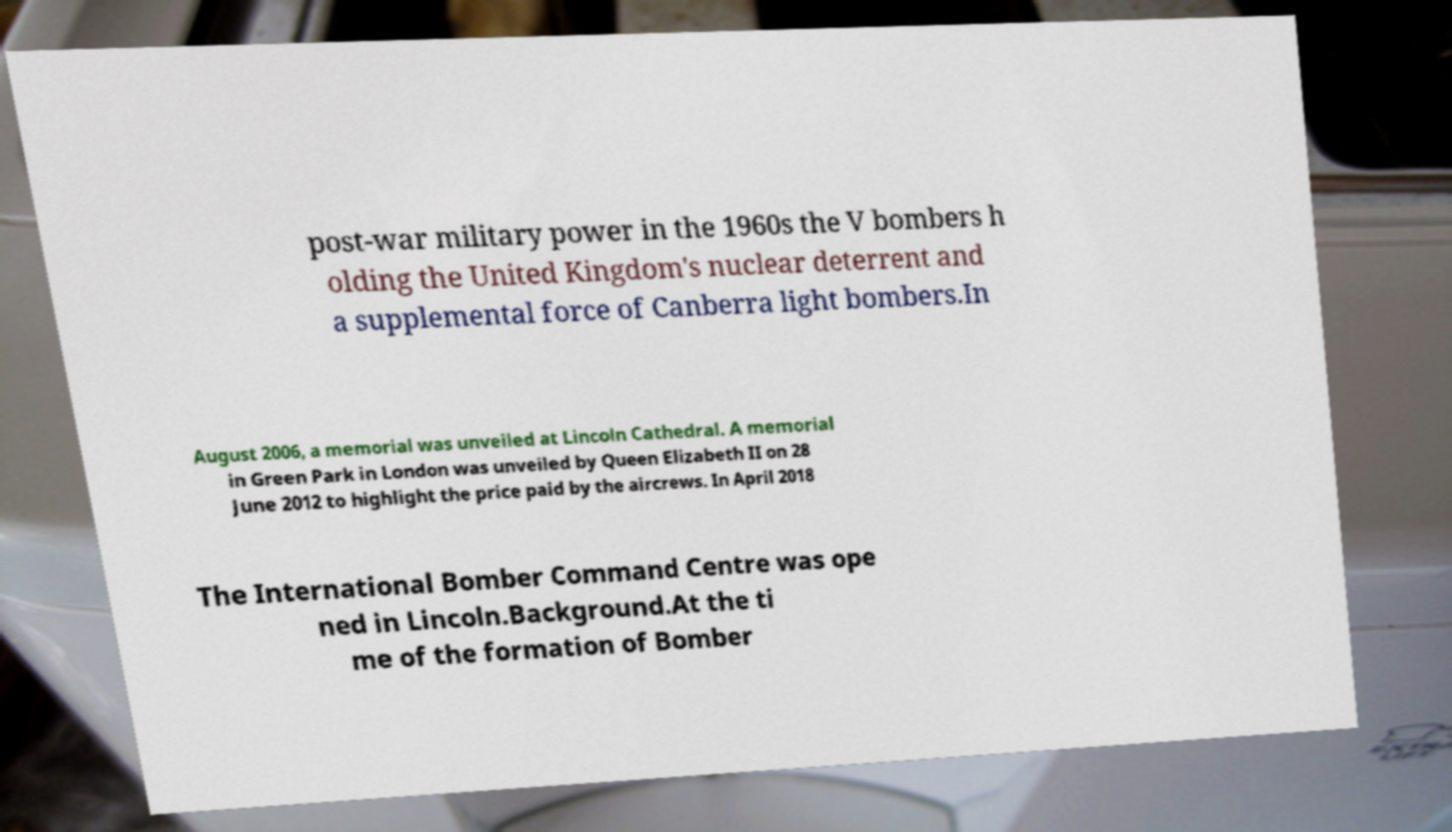Can you read and provide the text displayed in the image?This photo seems to have some interesting text. Can you extract and type it out for me? post-war military power in the 1960s the V bombers h olding the United Kingdom's nuclear deterrent and a supplemental force of Canberra light bombers.In August 2006, a memorial was unveiled at Lincoln Cathedral. A memorial in Green Park in London was unveiled by Queen Elizabeth II on 28 June 2012 to highlight the price paid by the aircrews. In April 2018 The International Bomber Command Centre was ope ned in Lincoln.Background.At the ti me of the formation of Bomber 